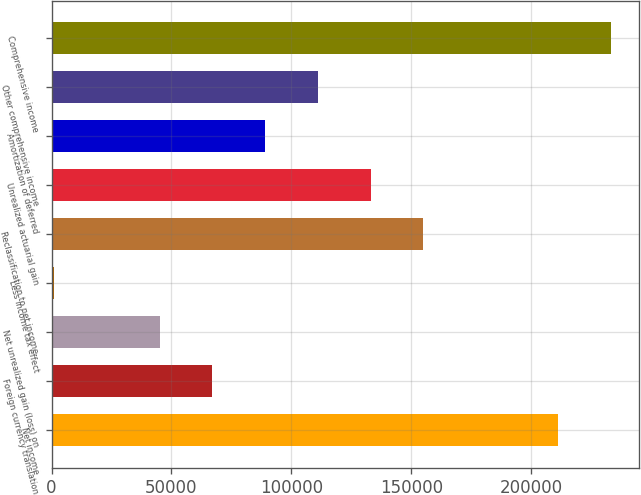<chart> <loc_0><loc_0><loc_500><loc_500><bar_chart><fcel>Net income<fcel>Foreign currency translation<fcel>Net unrealized gain (loss) on<fcel>Less income tax effect<fcel>Reclassification to net income<fcel>Unrealized actuarial gain<fcel>Amortization of deferred<fcel>Other comprehensive income<fcel>Comprehensive income<nl><fcel>211293<fcel>67073.7<fcel>45073.8<fcel>1074<fcel>155073<fcel>133073<fcel>89073.6<fcel>111074<fcel>233293<nl></chart> 